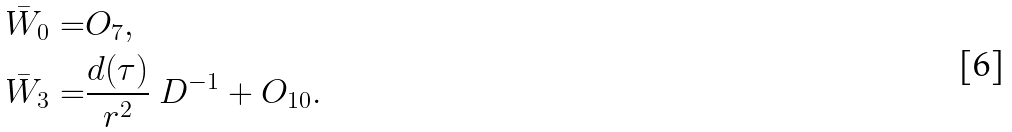Convert formula to latex. <formula><loc_0><loc_0><loc_500><loc_500>\bar { W } _ { 0 } = & O _ { 7 } , \\ \bar { W } _ { 3 } = & \frac { d ( \tau ) } { r ^ { 2 } } \ D ^ { - 1 } + O _ { 1 0 } .</formula> 